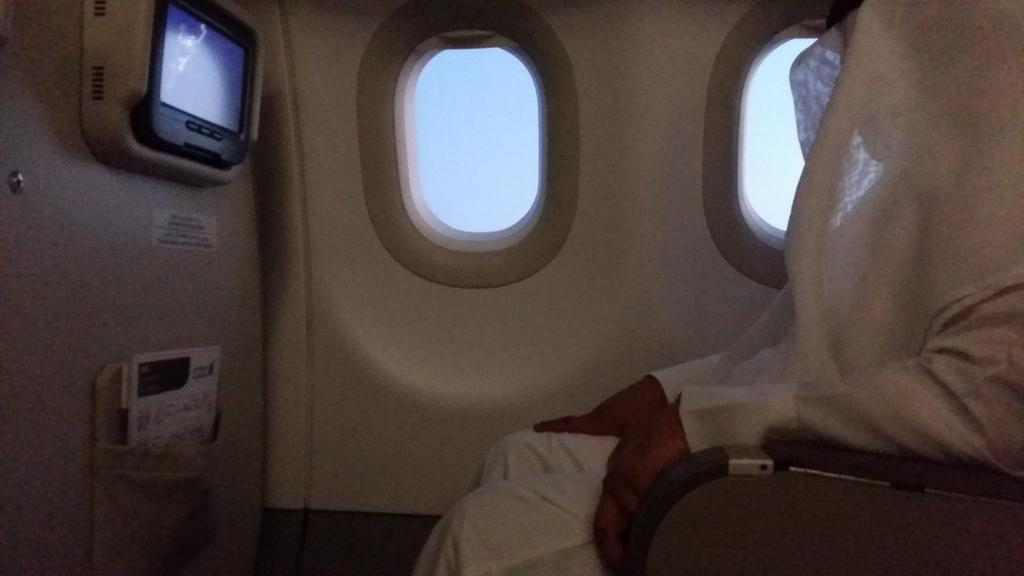What type of location is depicted in the image? The image shows the inside view of an airplane. Can you describe the person in the airplane? There is a person sitting in the airplane. What feature allows passengers to see outside the airplane? There are windows in the airplane. What type of entertainment device is present in the airplane? There is a television in the airplane. What other objects can be seen in the airplane? There are other objects visible in the airplane. What time is the branch visible in the image? There is no branch visible in the image; it is set inside an airplane. Who is the owner of the airplane in the image? The image does not provide information about the ownership of the airplane. 